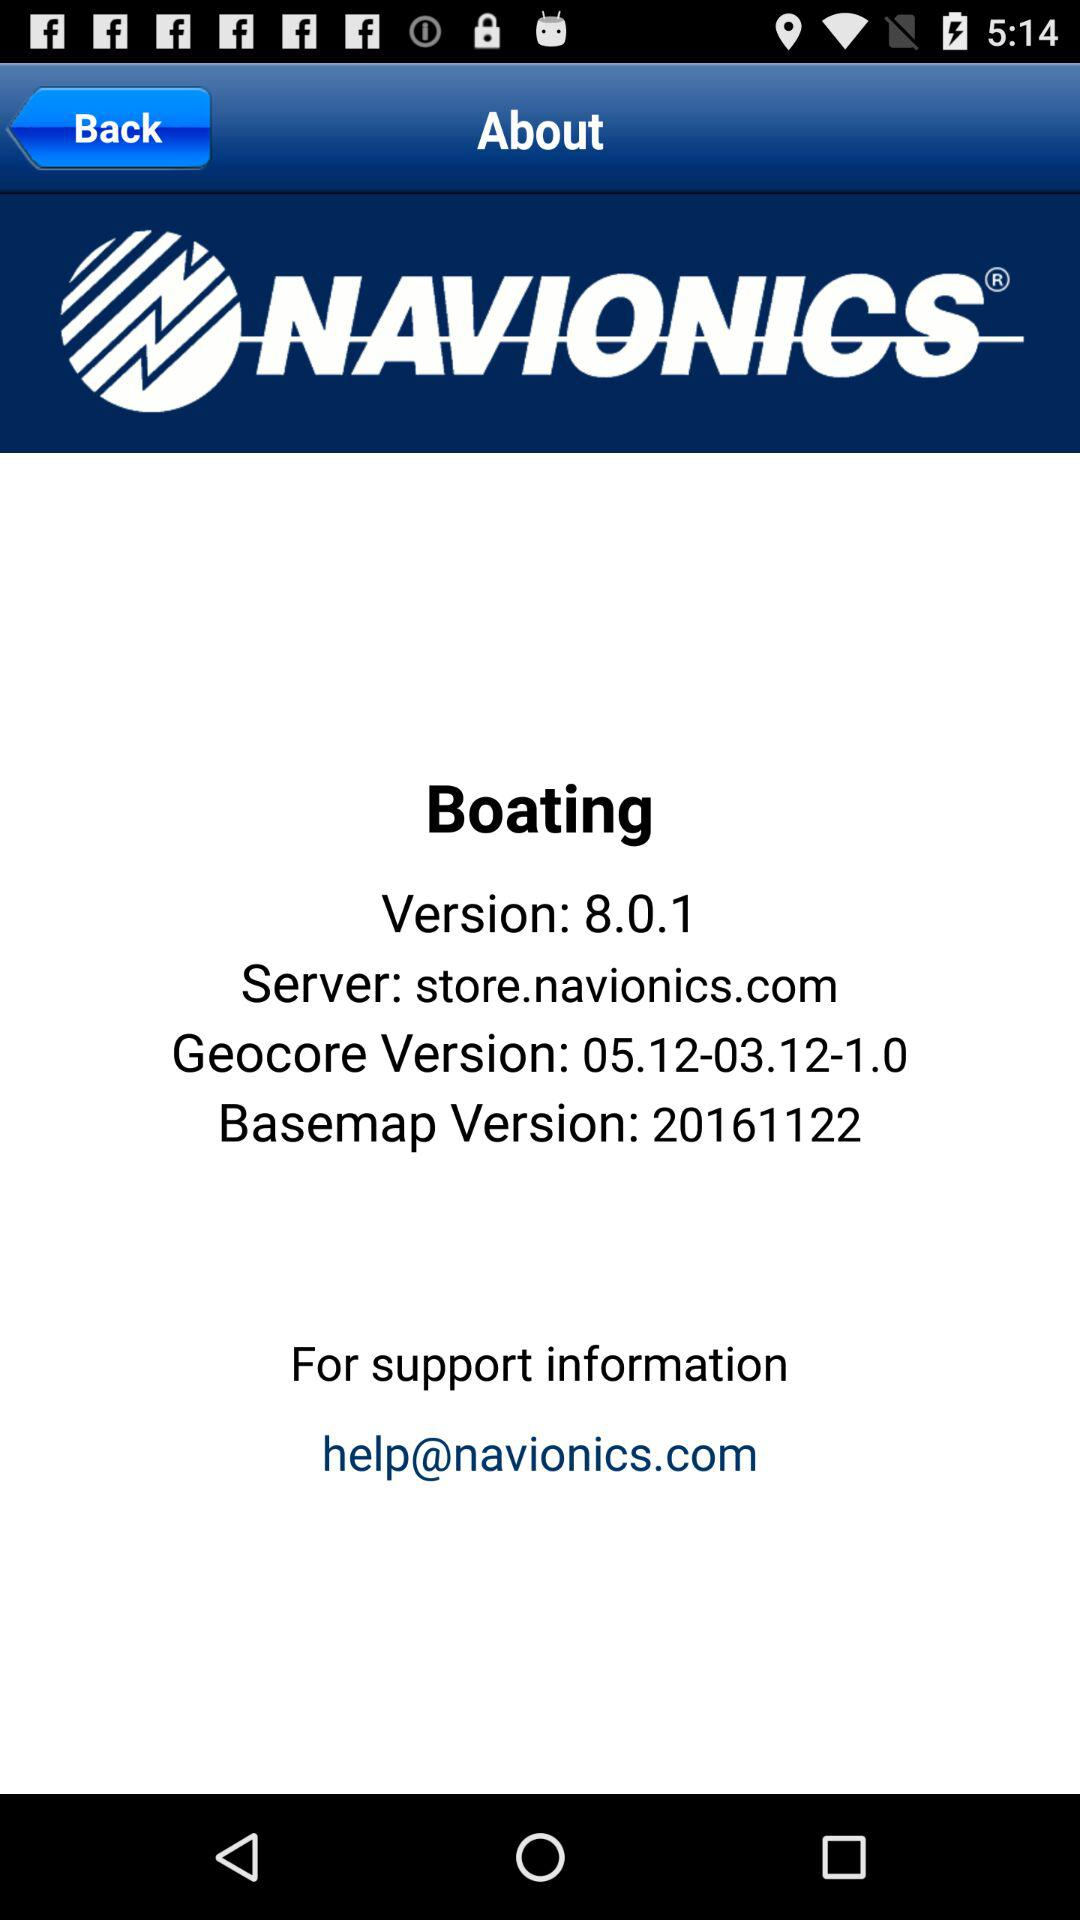What's the application server name? The application server name is "store.navionics.com". 